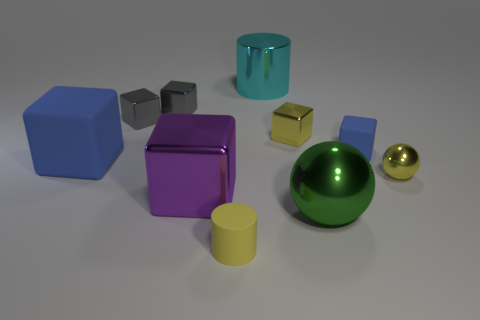What number of other things are the same size as the yellow metallic sphere?
Your response must be concise. 5. What shape is the tiny yellow metallic thing that is behind the blue block that is on the right side of the blue rubber cube that is to the left of the tiny yellow rubber cylinder?
Your response must be concise. Cube. There is a big metallic object that is both to the right of the purple thing and in front of the large blue block; what is its shape?
Ensure brevity in your answer.  Sphere. How many things are either yellow metallic balls or rubber things that are on the right side of the big purple object?
Provide a short and direct response. 3. Is the cyan cylinder made of the same material as the purple thing?
Provide a succinct answer. Yes. How many other things are the same shape as the big purple object?
Your answer should be compact. 5. There is a shiny object that is both right of the large cyan metallic cylinder and behind the large blue thing; how big is it?
Your answer should be compact. Small. What number of rubber objects are either large red balls or green spheres?
Keep it short and to the point. 0. There is a tiny yellow metal object on the left side of the tiny blue rubber thing; is it the same shape as the small yellow thing on the left side of the big cyan cylinder?
Provide a short and direct response. No. Is there a tiny cube that has the same material as the large blue block?
Offer a terse response. Yes. 